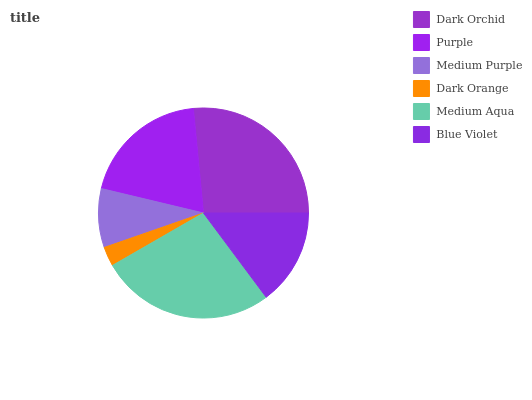Is Dark Orange the minimum?
Answer yes or no. Yes. Is Medium Aqua the maximum?
Answer yes or no. Yes. Is Purple the minimum?
Answer yes or no. No. Is Purple the maximum?
Answer yes or no. No. Is Dark Orchid greater than Purple?
Answer yes or no. Yes. Is Purple less than Dark Orchid?
Answer yes or no. Yes. Is Purple greater than Dark Orchid?
Answer yes or no. No. Is Dark Orchid less than Purple?
Answer yes or no. No. Is Purple the high median?
Answer yes or no. Yes. Is Blue Violet the low median?
Answer yes or no. Yes. Is Dark Orchid the high median?
Answer yes or no. No. Is Purple the low median?
Answer yes or no. No. 